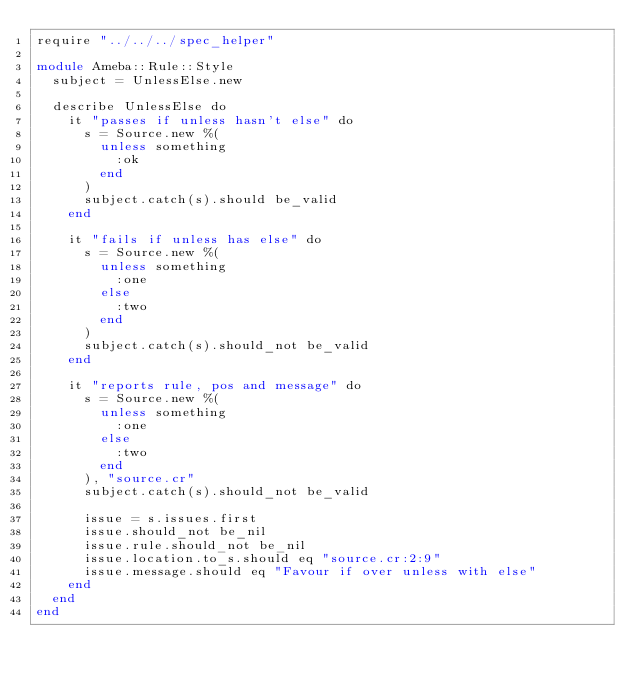<code> <loc_0><loc_0><loc_500><loc_500><_Crystal_>require "../../../spec_helper"

module Ameba::Rule::Style
  subject = UnlessElse.new

  describe UnlessElse do
    it "passes if unless hasn't else" do
      s = Source.new %(
        unless something
          :ok
        end
      )
      subject.catch(s).should be_valid
    end

    it "fails if unless has else" do
      s = Source.new %(
        unless something
          :one
        else
          :two
        end
      )
      subject.catch(s).should_not be_valid
    end

    it "reports rule, pos and message" do
      s = Source.new %(
        unless something
          :one
        else
          :two
        end
      ), "source.cr"
      subject.catch(s).should_not be_valid

      issue = s.issues.first
      issue.should_not be_nil
      issue.rule.should_not be_nil
      issue.location.to_s.should eq "source.cr:2:9"
      issue.message.should eq "Favour if over unless with else"
    end
  end
end
</code> 